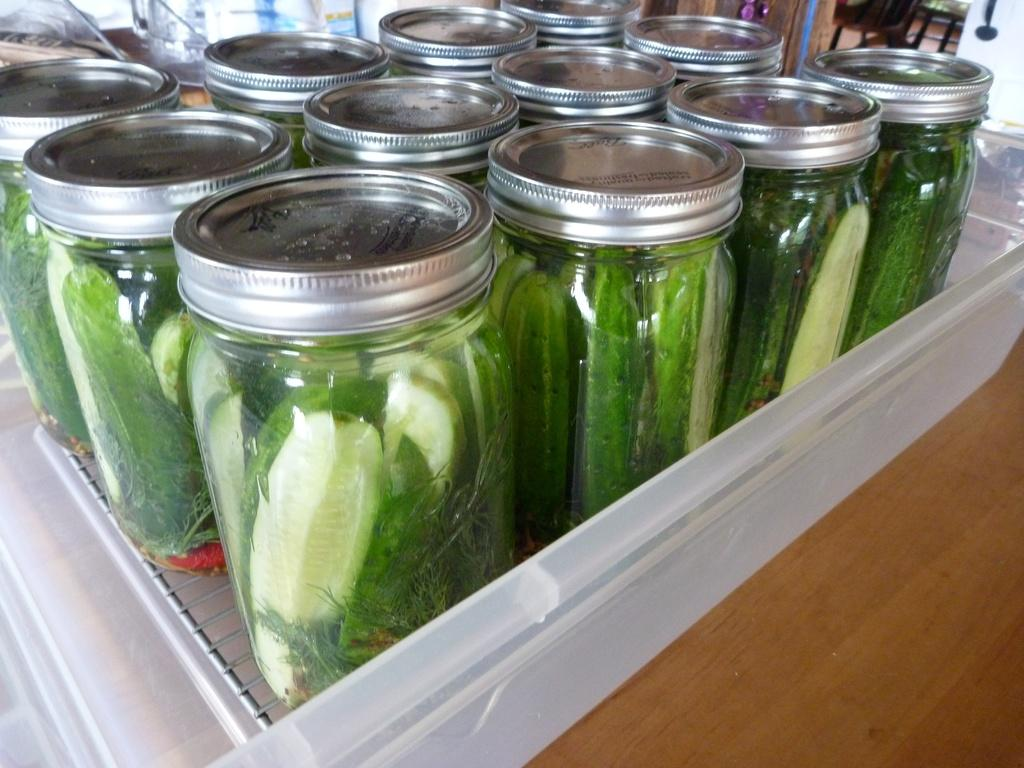What is inside the box that is visible in the image? There is a box with jars in the image. What do the jars contain? The jars contain cream and green color items. What is the color of the surface on which the box is placed? The box is on a brown color surface. Can you describe any other objects visible in the image? There are additional objects visible in the image, but their specific details are not mentioned in the provided facts. What songs can be heard playing in the background of the image? There is no mention of any songs or background music in the provided facts, so it cannot be determined from the image. 